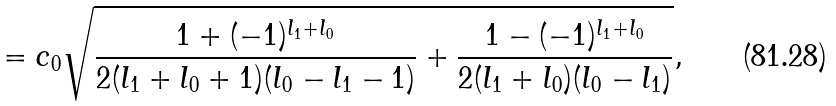Convert formula to latex. <formula><loc_0><loc_0><loc_500><loc_500>= c _ { 0 } \sqrt { \frac { 1 + ( - 1 ) ^ { l _ { 1 } + l _ { 0 } } } { 2 ( l _ { 1 } + l _ { 0 } + 1 ) ( l _ { 0 } - l _ { 1 } - 1 ) } + \frac { 1 - ( - 1 ) ^ { l _ { 1 } + l _ { 0 } } } { 2 ( l _ { 1 } + l _ { 0 } ) ( l _ { 0 } - l _ { 1 } ) } } ,</formula> 